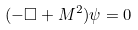Convert formula to latex. <formula><loc_0><loc_0><loc_500><loc_500>( - \square + M ^ { 2 } ) \psi = 0</formula> 